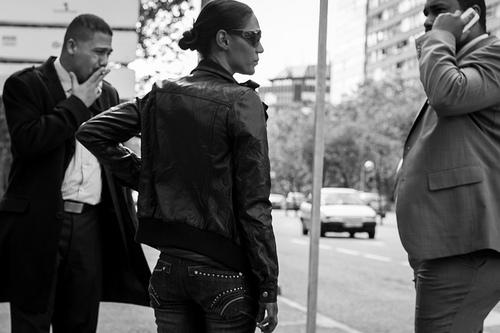Which objects can you identify on the street corner? On the street corner, there are three people, a sign post, a metal pole, and a building with windows nearby. Can you identify any accessory that the woman is wearing on her face? The woman is wearing sunglasses on her face. What emotions and atmosphere can be observed in this image? The image has a casual, urban atmosphere, and the expressions of the people suggest a sense of calmness and relaxation. What type of vehicle can be seen driving on the road? There is a white car with visible headlights driving on the road. Describe the location where this image was taken. This image was taken on a street with a car driving on the road, buildings, a sidewalk, and trees growing across the street. What type of outfit is the man standing on the right wearing? The man is wearing a business suit and holding his hand to his mouth. What is the primary activity happening in the image? Three people are standing on the side of the road, with one man talking on a cell phone and another man smoking a cigarette. Describe any interactions between people and objects in the image. A man is smoking a cigarette, another man is talking on a cell phone, and a woman is wearing sunglasses and a leather coat. List the items being worn by the woman in the image. The woman is wearing sunglasses, has her hair in a bun, and is wearing a dark leather jacket and jeans with metal studs on the pants. Count the total number of people present in the image. There are three people standing on the side of the road. A purple umbrella can be seen on the far left corner of the image. No, it's not mentioned in the image. What are the people doing on the side of the road? Standing. What type of outerwear is the man wearing? A black coat. Identify the object on the corner of the street. A metal pole. What vegetation can you observe across the street? Trees. What type of clothing is the man wearing? A business suit. How many people are standing on the side of the road? Three. What is the object at coordinates X:362 Y:3? A building with windows. Provide a brief description for the scene. A woman wearing sunglasses with her hair up, a man talking on a phone, and another man smoking a cigarette. What action is the man performing while holding his hand to his mouth? Smoking a cigarette. What color is the car that's driving on the road? White. What is the man on the left standing behind? A building. What type of jacket is the woman wearing? A dark leather jacket. What is the man using to communicate? A phone. Describe the hairstyle of the woman. Her hair is in a bun. List the clothing items worn by the lady. Leather jacket, sunglasses, and jeans. What material are the studs on the pants made of? Metal. Choose the correct caption for the lady's outfit: B. A woman wearing a leather jacket and jeans Identify the woman's coat material. Leather. Determine the facial accessory worn by the lady. Sunglasses. 